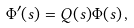<formula> <loc_0><loc_0><loc_500><loc_500>\Phi ^ { \prime } ( s ) = Q ( s ) \Phi ( s ) \, ,</formula> 